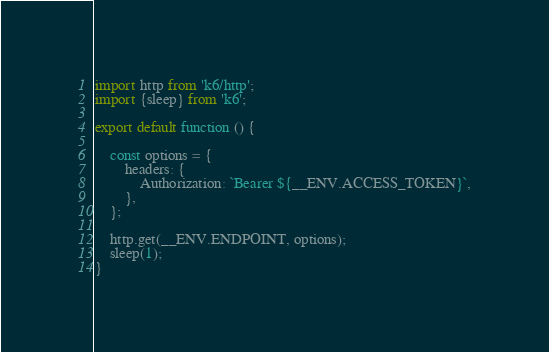Convert code to text. <code><loc_0><loc_0><loc_500><loc_500><_JavaScript_>import http from 'k6/http';
import {sleep} from 'k6';

export default function () {

    const options = {
        headers: {
            Authorization: `Bearer ${__ENV.ACCESS_TOKEN}`,
        },
    };

    http.get(__ENV.ENDPOINT, options);
    sleep(1);
}
</code> 